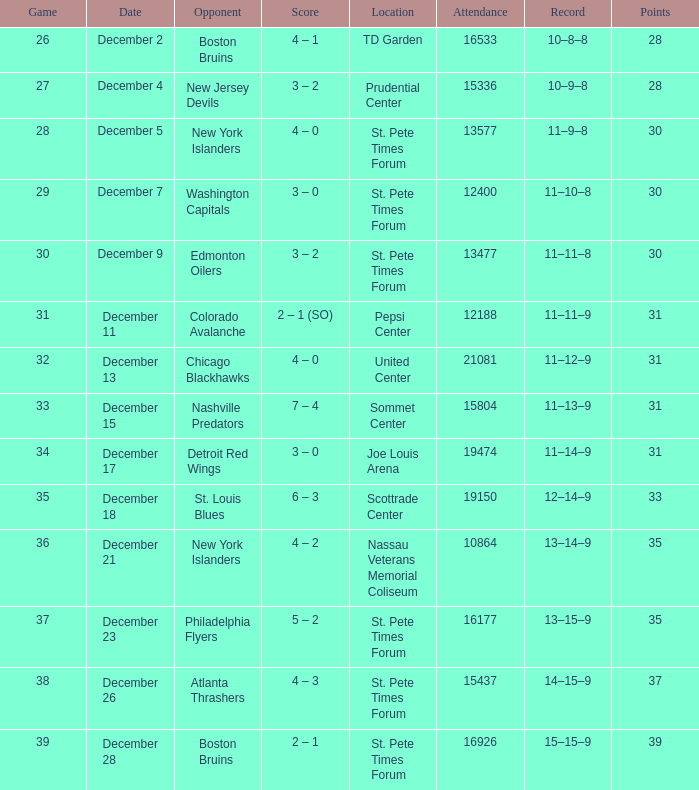At which game was the largest crowd present? 21081.0. 